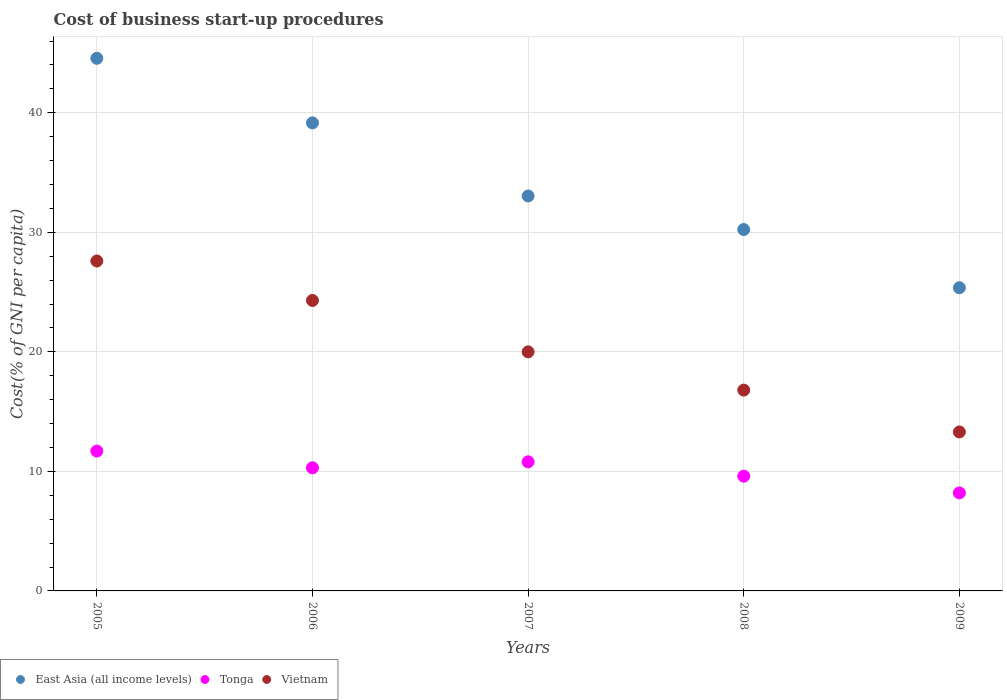What is the cost of business start-up procedures in East Asia (all income levels) in 2009?
Your answer should be compact. 25.36. Across all years, what is the maximum cost of business start-up procedures in Vietnam?
Ensure brevity in your answer.  27.6. What is the total cost of business start-up procedures in Vietnam in the graph?
Make the answer very short. 102. What is the difference between the cost of business start-up procedures in Tonga in 2008 and that in 2009?
Ensure brevity in your answer.  1.4. What is the difference between the cost of business start-up procedures in Tonga in 2005 and the cost of business start-up procedures in Vietnam in 2009?
Give a very brief answer. -1.6. What is the average cost of business start-up procedures in East Asia (all income levels) per year?
Give a very brief answer. 34.47. In the year 2009, what is the difference between the cost of business start-up procedures in Vietnam and cost of business start-up procedures in Tonga?
Offer a terse response. 5.1. In how many years, is the cost of business start-up procedures in East Asia (all income levels) greater than 42 %?
Make the answer very short. 1. What is the ratio of the cost of business start-up procedures in East Asia (all income levels) in 2005 to that in 2008?
Make the answer very short. 1.47. Is the difference between the cost of business start-up procedures in Vietnam in 2007 and 2008 greater than the difference between the cost of business start-up procedures in Tonga in 2007 and 2008?
Offer a very short reply. Yes. What is the difference between the highest and the second highest cost of business start-up procedures in Vietnam?
Provide a succinct answer. 3.3. What is the difference between the highest and the lowest cost of business start-up procedures in Tonga?
Your answer should be very brief. 3.5. Is it the case that in every year, the sum of the cost of business start-up procedures in Vietnam and cost of business start-up procedures in Tonga  is greater than the cost of business start-up procedures in East Asia (all income levels)?
Keep it short and to the point. No. Does the cost of business start-up procedures in Tonga monotonically increase over the years?
Give a very brief answer. No. Is the cost of business start-up procedures in East Asia (all income levels) strictly greater than the cost of business start-up procedures in Tonga over the years?
Offer a terse response. Yes. How many dotlines are there?
Give a very brief answer. 3. Does the graph contain any zero values?
Ensure brevity in your answer.  No. How many legend labels are there?
Your response must be concise. 3. How are the legend labels stacked?
Make the answer very short. Horizontal. What is the title of the graph?
Make the answer very short. Cost of business start-up procedures. Does "Andorra" appear as one of the legend labels in the graph?
Ensure brevity in your answer.  No. What is the label or title of the Y-axis?
Your response must be concise. Cost(% of GNI per capita). What is the Cost(% of GNI per capita) of East Asia (all income levels) in 2005?
Offer a terse response. 44.56. What is the Cost(% of GNI per capita) in Tonga in 2005?
Make the answer very short. 11.7. What is the Cost(% of GNI per capita) in Vietnam in 2005?
Your answer should be compact. 27.6. What is the Cost(% of GNI per capita) in East Asia (all income levels) in 2006?
Offer a terse response. 39.16. What is the Cost(% of GNI per capita) of Tonga in 2006?
Your response must be concise. 10.3. What is the Cost(% of GNI per capita) in Vietnam in 2006?
Keep it short and to the point. 24.3. What is the Cost(% of GNI per capita) of East Asia (all income levels) in 2007?
Give a very brief answer. 33.04. What is the Cost(% of GNI per capita) in Tonga in 2007?
Your answer should be compact. 10.8. What is the Cost(% of GNI per capita) of Vietnam in 2007?
Provide a succinct answer. 20. What is the Cost(% of GNI per capita) of East Asia (all income levels) in 2008?
Offer a very short reply. 30.24. What is the Cost(% of GNI per capita) of East Asia (all income levels) in 2009?
Keep it short and to the point. 25.36. What is the Cost(% of GNI per capita) in Tonga in 2009?
Provide a short and direct response. 8.2. Across all years, what is the maximum Cost(% of GNI per capita) of East Asia (all income levels)?
Ensure brevity in your answer.  44.56. Across all years, what is the maximum Cost(% of GNI per capita) of Tonga?
Provide a succinct answer. 11.7. Across all years, what is the maximum Cost(% of GNI per capita) of Vietnam?
Offer a terse response. 27.6. Across all years, what is the minimum Cost(% of GNI per capita) in East Asia (all income levels)?
Make the answer very short. 25.36. Across all years, what is the minimum Cost(% of GNI per capita) of Vietnam?
Offer a terse response. 13.3. What is the total Cost(% of GNI per capita) of East Asia (all income levels) in the graph?
Make the answer very short. 172.35. What is the total Cost(% of GNI per capita) in Tonga in the graph?
Your answer should be compact. 50.6. What is the total Cost(% of GNI per capita) of Vietnam in the graph?
Give a very brief answer. 102. What is the difference between the Cost(% of GNI per capita) in East Asia (all income levels) in 2005 and that in 2006?
Your response must be concise. 5.4. What is the difference between the Cost(% of GNI per capita) in East Asia (all income levels) in 2005 and that in 2007?
Your answer should be compact. 11.52. What is the difference between the Cost(% of GNI per capita) of Tonga in 2005 and that in 2007?
Keep it short and to the point. 0.9. What is the difference between the Cost(% of GNI per capita) of Vietnam in 2005 and that in 2007?
Your answer should be compact. 7.6. What is the difference between the Cost(% of GNI per capita) in East Asia (all income levels) in 2005 and that in 2008?
Make the answer very short. 14.32. What is the difference between the Cost(% of GNI per capita) of Tonga in 2005 and that in 2008?
Make the answer very short. 2.1. What is the difference between the Cost(% of GNI per capita) in Vietnam in 2005 and that in 2008?
Your answer should be compact. 10.8. What is the difference between the Cost(% of GNI per capita) of East Asia (all income levels) in 2005 and that in 2009?
Your answer should be very brief. 19.19. What is the difference between the Cost(% of GNI per capita) of Tonga in 2005 and that in 2009?
Your answer should be very brief. 3.5. What is the difference between the Cost(% of GNI per capita) in Vietnam in 2005 and that in 2009?
Your answer should be compact. 14.3. What is the difference between the Cost(% of GNI per capita) of East Asia (all income levels) in 2006 and that in 2007?
Offer a very short reply. 6.12. What is the difference between the Cost(% of GNI per capita) in East Asia (all income levels) in 2006 and that in 2008?
Your response must be concise. 8.92. What is the difference between the Cost(% of GNI per capita) in Vietnam in 2006 and that in 2008?
Your answer should be very brief. 7.5. What is the difference between the Cost(% of GNI per capita) of East Asia (all income levels) in 2006 and that in 2009?
Provide a short and direct response. 13.79. What is the difference between the Cost(% of GNI per capita) of East Asia (all income levels) in 2007 and that in 2008?
Provide a short and direct response. 2.8. What is the difference between the Cost(% of GNI per capita) in Tonga in 2007 and that in 2008?
Give a very brief answer. 1.2. What is the difference between the Cost(% of GNI per capita) in Vietnam in 2007 and that in 2008?
Provide a short and direct response. 3.2. What is the difference between the Cost(% of GNI per capita) of East Asia (all income levels) in 2007 and that in 2009?
Make the answer very short. 7.68. What is the difference between the Cost(% of GNI per capita) of Tonga in 2007 and that in 2009?
Give a very brief answer. 2.6. What is the difference between the Cost(% of GNI per capita) in Vietnam in 2007 and that in 2009?
Provide a short and direct response. 6.7. What is the difference between the Cost(% of GNI per capita) in East Asia (all income levels) in 2008 and that in 2009?
Your answer should be compact. 4.87. What is the difference between the Cost(% of GNI per capita) in Tonga in 2008 and that in 2009?
Keep it short and to the point. 1.4. What is the difference between the Cost(% of GNI per capita) in East Asia (all income levels) in 2005 and the Cost(% of GNI per capita) in Tonga in 2006?
Ensure brevity in your answer.  34.26. What is the difference between the Cost(% of GNI per capita) in East Asia (all income levels) in 2005 and the Cost(% of GNI per capita) in Vietnam in 2006?
Offer a very short reply. 20.26. What is the difference between the Cost(% of GNI per capita) of East Asia (all income levels) in 2005 and the Cost(% of GNI per capita) of Tonga in 2007?
Offer a very short reply. 33.76. What is the difference between the Cost(% of GNI per capita) of East Asia (all income levels) in 2005 and the Cost(% of GNI per capita) of Vietnam in 2007?
Make the answer very short. 24.56. What is the difference between the Cost(% of GNI per capita) in Tonga in 2005 and the Cost(% of GNI per capita) in Vietnam in 2007?
Your response must be concise. -8.3. What is the difference between the Cost(% of GNI per capita) of East Asia (all income levels) in 2005 and the Cost(% of GNI per capita) of Tonga in 2008?
Offer a terse response. 34.96. What is the difference between the Cost(% of GNI per capita) in East Asia (all income levels) in 2005 and the Cost(% of GNI per capita) in Vietnam in 2008?
Keep it short and to the point. 27.76. What is the difference between the Cost(% of GNI per capita) in Tonga in 2005 and the Cost(% of GNI per capita) in Vietnam in 2008?
Your answer should be compact. -5.1. What is the difference between the Cost(% of GNI per capita) in East Asia (all income levels) in 2005 and the Cost(% of GNI per capita) in Tonga in 2009?
Give a very brief answer. 36.36. What is the difference between the Cost(% of GNI per capita) in East Asia (all income levels) in 2005 and the Cost(% of GNI per capita) in Vietnam in 2009?
Provide a short and direct response. 31.26. What is the difference between the Cost(% of GNI per capita) in East Asia (all income levels) in 2006 and the Cost(% of GNI per capita) in Tonga in 2007?
Make the answer very short. 28.36. What is the difference between the Cost(% of GNI per capita) of East Asia (all income levels) in 2006 and the Cost(% of GNI per capita) of Vietnam in 2007?
Provide a short and direct response. 19.16. What is the difference between the Cost(% of GNI per capita) in East Asia (all income levels) in 2006 and the Cost(% of GNI per capita) in Tonga in 2008?
Your response must be concise. 29.56. What is the difference between the Cost(% of GNI per capita) of East Asia (all income levels) in 2006 and the Cost(% of GNI per capita) of Vietnam in 2008?
Your answer should be very brief. 22.36. What is the difference between the Cost(% of GNI per capita) in East Asia (all income levels) in 2006 and the Cost(% of GNI per capita) in Tonga in 2009?
Provide a succinct answer. 30.96. What is the difference between the Cost(% of GNI per capita) of East Asia (all income levels) in 2006 and the Cost(% of GNI per capita) of Vietnam in 2009?
Give a very brief answer. 25.86. What is the difference between the Cost(% of GNI per capita) in East Asia (all income levels) in 2007 and the Cost(% of GNI per capita) in Tonga in 2008?
Your response must be concise. 23.44. What is the difference between the Cost(% of GNI per capita) of East Asia (all income levels) in 2007 and the Cost(% of GNI per capita) of Vietnam in 2008?
Provide a succinct answer. 16.24. What is the difference between the Cost(% of GNI per capita) of East Asia (all income levels) in 2007 and the Cost(% of GNI per capita) of Tonga in 2009?
Provide a succinct answer. 24.84. What is the difference between the Cost(% of GNI per capita) of East Asia (all income levels) in 2007 and the Cost(% of GNI per capita) of Vietnam in 2009?
Your response must be concise. 19.74. What is the difference between the Cost(% of GNI per capita) in East Asia (all income levels) in 2008 and the Cost(% of GNI per capita) in Tonga in 2009?
Make the answer very short. 22.04. What is the difference between the Cost(% of GNI per capita) of East Asia (all income levels) in 2008 and the Cost(% of GNI per capita) of Vietnam in 2009?
Provide a succinct answer. 16.94. What is the difference between the Cost(% of GNI per capita) in Tonga in 2008 and the Cost(% of GNI per capita) in Vietnam in 2009?
Your response must be concise. -3.7. What is the average Cost(% of GNI per capita) of East Asia (all income levels) per year?
Provide a short and direct response. 34.47. What is the average Cost(% of GNI per capita) in Tonga per year?
Your response must be concise. 10.12. What is the average Cost(% of GNI per capita) in Vietnam per year?
Give a very brief answer. 20.4. In the year 2005, what is the difference between the Cost(% of GNI per capita) in East Asia (all income levels) and Cost(% of GNI per capita) in Tonga?
Your response must be concise. 32.86. In the year 2005, what is the difference between the Cost(% of GNI per capita) in East Asia (all income levels) and Cost(% of GNI per capita) in Vietnam?
Make the answer very short. 16.96. In the year 2005, what is the difference between the Cost(% of GNI per capita) of Tonga and Cost(% of GNI per capita) of Vietnam?
Your response must be concise. -15.9. In the year 2006, what is the difference between the Cost(% of GNI per capita) of East Asia (all income levels) and Cost(% of GNI per capita) of Tonga?
Your answer should be very brief. 28.86. In the year 2006, what is the difference between the Cost(% of GNI per capita) in East Asia (all income levels) and Cost(% of GNI per capita) in Vietnam?
Your answer should be compact. 14.86. In the year 2006, what is the difference between the Cost(% of GNI per capita) of Tonga and Cost(% of GNI per capita) of Vietnam?
Give a very brief answer. -14. In the year 2007, what is the difference between the Cost(% of GNI per capita) in East Asia (all income levels) and Cost(% of GNI per capita) in Tonga?
Your answer should be very brief. 22.24. In the year 2007, what is the difference between the Cost(% of GNI per capita) of East Asia (all income levels) and Cost(% of GNI per capita) of Vietnam?
Make the answer very short. 13.04. In the year 2007, what is the difference between the Cost(% of GNI per capita) of Tonga and Cost(% of GNI per capita) of Vietnam?
Offer a very short reply. -9.2. In the year 2008, what is the difference between the Cost(% of GNI per capita) of East Asia (all income levels) and Cost(% of GNI per capita) of Tonga?
Offer a very short reply. 20.64. In the year 2008, what is the difference between the Cost(% of GNI per capita) in East Asia (all income levels) and Cost(% of GNI per capita) in Vietnam?
Offer a very short reply. 13.44. In the year 2008, what is the difference between the Cost(% of GNI per capita) in Tonga and Cost(% of GNI per capita) in Vietnam?
Keep it short and to the point. -7.2. In the year 2009, what is the difference between the Cost(% of GNI per capita) of East Asia (all income levels) and Cost(% of GNI per capita) of Tonga?
Your response must be concise. 17.16. In the year 2009, what is the difference between the Cost(% of GNI per capita) in East Asia (all income levels) and Cost(% of GNI per capita) in Vietnam?
Ensure brevity in your answer.  12.06. What is the ratio of the Cost(% of GNI per capita) of East Asia (all income levels) in 2005 to that in 2006?
Keep it short and to the point. 1.14. What is the ratio of the Cost(% of GNI per capita) of Tonga in 2005 to that in 2006?
Offer a very short reply. 1.14. What is the ratio of the Cost(% of GNI per capita) in Vietnam in 2005 to that in 2006?
Offer a terse response. 1.14. What is the ratio of the Cost(% of GNI per capita) in East Asia (all income levels) in 2005 to that in 2007?
Make the answer very short. 1.35. What is the ratio of the Cost(% of GNI per capita) of Tonga in 2005 to that in 2007?
Provide a succinct answer. 1.08. What is the ratio of the Cost(% of GNI per capita) of Vietnam in 2005 to that in 2007?
Provide a short and direct response. 1.38. What is the ratio of the Cost(% of GNI per capita) in East Asia (all income levels) in 2005 to that in 2008?
Keep it short and to the point. 1.47. What is the ratio of the Cost(% of GNI per capita) of Tonga in 2005 to that in 2008?
Make the answer very short. 1.22. What is the ratio of the Cost(% of GNI per capita) in Vietnam in 2005 to that in 2008?
Give a very brief answer. 1.64. What is the ratio of the Cost(% of GNI per capita) in East Asia (all income levels) in 2005 to that in 2009?
Make the answer very short. 1.76. What is the ratio of the Cost(% of GNI per capita) in Tonga in 2005 to that in 2009?
Provide a short and direct response. 1.43. What is the ratio of the Cost(% of GNI per capita) in Vietnam in 2005 to that in 2009?
Keep it short and to the point. 2.08. What is the ratio of the Cost(% of GNI per capita) in East Asia (all income levels) in 2006 to that in 2007?
Offer a very short reply. 1.19. What is the ratio of the Cost(% of GNI per capita) of Tonga in 2006 to that in 2007?
Offer a very short reply. 0.95. What is the ratio of the Cost(% of GNI per capita) of Vietnam in 2006 to that in 2007?
Ensure brevity in your answer.  1.22. What is the ratio of the Cost(% of GNI per capita) of East Asia (all income levels) in 2006 to that in 2008?
Make the answer very short. 1.29. What is the ratio of the Cost(% of GNI per capita) of Tonga in 2006 to that in 2008?
Provide a succinct answer. 1.07. What is the ratio of the Cost(% of GNI per capita) of Vietnam in 2006 to that in 2008?
Your answer should be compact. 1.45. What is the ratio of the Cost(% of GNI per capita) of East Asia (all income levels) in 2006 to that in 2009?
Your response must be concise. 1.54. What is the ratio of the Cost(% of GNI per capita) in Tonga in 2006 to that in 2009?
Ensure brevity in your answer.  1.26. What is the ratio of the Cost(% of GNI per capita) of Vietnam in 2006 to that in 2009?
Your answer should be very brief. 1.83. What is the ratio of the Cost(% of GNI per capita) in East Asia (all income levels) in 2007 to that in 2008?
Offer a terse response. 1.09. What is the ratio of the Cost(% of GNI per capita) of Tonga in 2007 to that in 2008?
Give a very brief answer. 1.12. What is the ratio of the Cost(% of GNI per capita) of Vietnam in 2007 to that in 2008?
Offer a very short reply. 1.19. What is the ratio of the Cost(% of GNI per capita) in East Asia (all income levels) in 2007 to that in 2009?
Provide a short and direct response. 1.3. What is the ratio of the Cost(% of GNI per capita) in Tonga in 2007 to that in 2009?
Make the answer very short. 1.32. What is the ratio of the Cost(% of GNI per capita) of Vietnam in 2007 to that in 2009?
Offer a very short reply. 1.5. What is the ratio of the Cost(% of GNI per capita) in East Asia (all income levels) in 2008 to that in 2009?
Offer a terse response. 1.19. What is the ratio of the Cost(% of GNI per capita) of Tonga in 2008 to that in 2009?
Keep it short and to the point. 1.17. What is the ratio of the Cost(% of GNI per capita) of Vietnam in 2008 to that in 2009?
Give a very brief answer. 1.26. What is the difference between the highest and the second highest Cost(% of GNI per capita) of East Asia (all income levels)?
Your response must be concise. 5.4. What is the difference between the highest and the second highest Cost(% of GNI per capita) of Vietnam?
Offer a very short reply. 3.3. What is the difference between the highest and the lowest Cost(% of GNI per capita) in East Asia (all income levels)?
Provide a short and direct response. 19.19. What is the difference between the highest and the lowest Cost(% of GNI per capita) in Vietnam?
Keep it short and to the point. 14.3. 